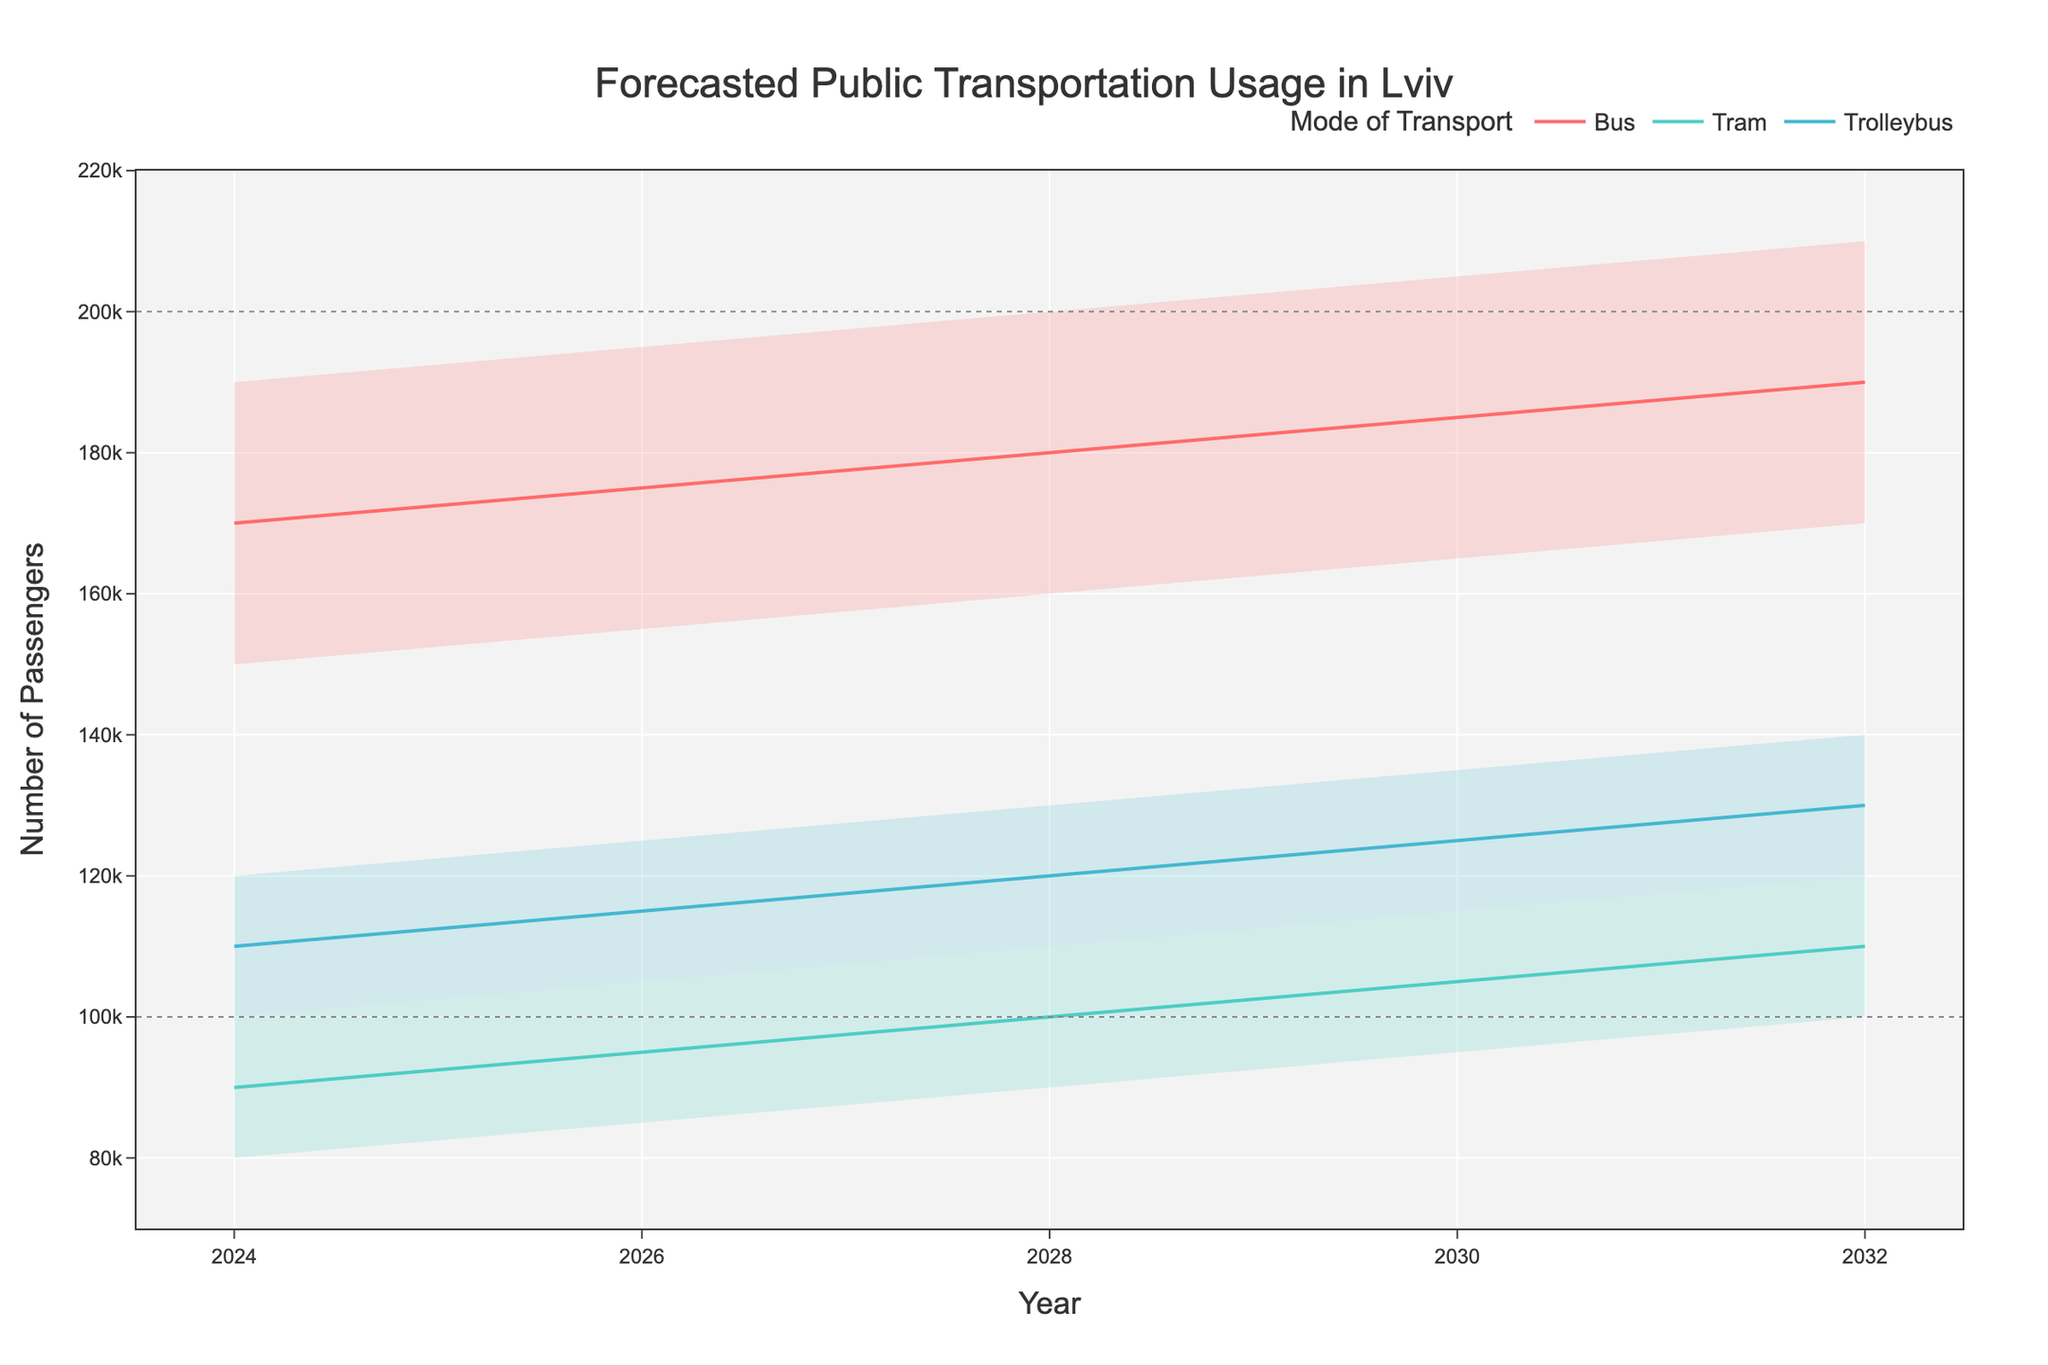What is the title of the figure? The title is usually located above the chart, at the top center. It is written in larger font size to attract attention.
Answer: Forecasted Public Transportation Usage in Lviv What modes of public transportation are displayed in the figure? The legend typically identifies the different modes of transportation, usually represented by different colors.
Answer: Bus, Tram, Trolleybus Which mode of transportation has the highest predicted mid-range value in 2024? Find the mid-range line (solid lines) in 2024 and compare the values for each mode. The highest value corresponds to the highest line in that year.
Answer: Bus What is the expected range of passengers for the tram in 2028? Identify the tram's area (bounded by the shaded region) for the year 2028. The range is between the lowest and highest points of this region.
Answer: 90,000 to 110,000 How does the expected number of passengers for bus change from 2024 to 2032? Examine the mid value or the middle line for the bus mode. Note the value at 2024 and 2032 and then determine whether it increases, decreases, or stays the same.
Answer: Increases Which year is the prediction for mid-value trolleybus usage the highest? Locate the mid-value lines for the trolleybus and compare the heights across different years.
Answer: 2032 What is the difference between the high and low predictions for tram passengers in 2030? Identify the high and low lines for the tram in the year 2030 and subtract the low value from the high value to get the difference.
Answer: 20,000 If the actual number of tram passengers in 2028 turns out to be 97,000, does it fall within the predicted range? Check the shaded area boundaries for trams in 2028. If 97,000 is between the low and high values, it falls within the range.
Answer: Yes Which transport mode has the smallest range of forecasted passengers in 2024? Compare the distance between the high and low predictions for each mode in 2024. The smallest gap indicates the smallest range.
Answer: Tram 